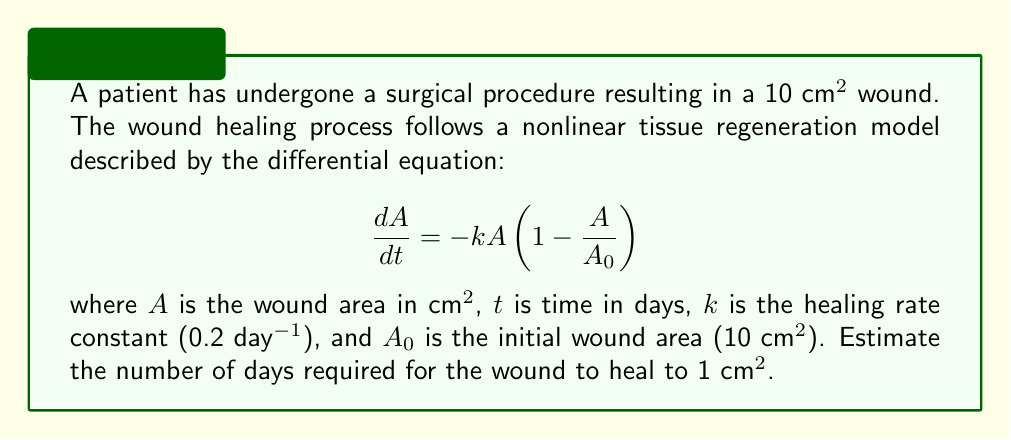Help me with this question. To solve this problem, we need to integrate the given differential equation and solve for t when A = 1 cm^2. Here's the step-by-step process:

1) Rearrange the differential equation:
   $$\frac{dA}{A(1-\frac{A}{A_0})} = -k dt$$

2) Integrate both sides:
   $$\int_{A_0}^A \frac{dA}{A(1-\frac{A}{A_0})} = -k \int_0^t dt$$

3) Solve the left-hand side integral:
   $$[\ln|A| + \ln|A_0 - A|]_{A_0}^A = -kt$$

4) Substitute the limits:
   $$(\ln|A| + \ln|A_0 - A|) - (\ln|A_0| + \ln|A_0 - A_0|) = -kt$$

5) Simplify:
   $$\ln|\frac{A}{A_0}| + \ln|\frac{A_0 - A}{A_0}| = -kt$$

6) Use the properties of logarithms:
   $$\ln|\frac{A(A_0 - A)}{A_0^2}| = -kt$$

7) Substitute the known values (A = 1 cm^2, A_0 = 10 cm^2, k = 0.2 day^-1):
   $$\ln|\frac{1(10 - 1)}{10^2}| = -0.2t$$

8) Solve for t:
   $$t = -\frac{1}{0.2} \ln|\frac{9}{100}| \approx 11.51$$

Therefore, it will take approximately 11.51 days for the wound to heal to 1 cm^2.
Answer: 11.51 days 